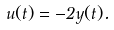<formula> <loc_0><loc_0><loc_500><loc_500>u ( t ) = - 2 y ( t ) .</formula> 